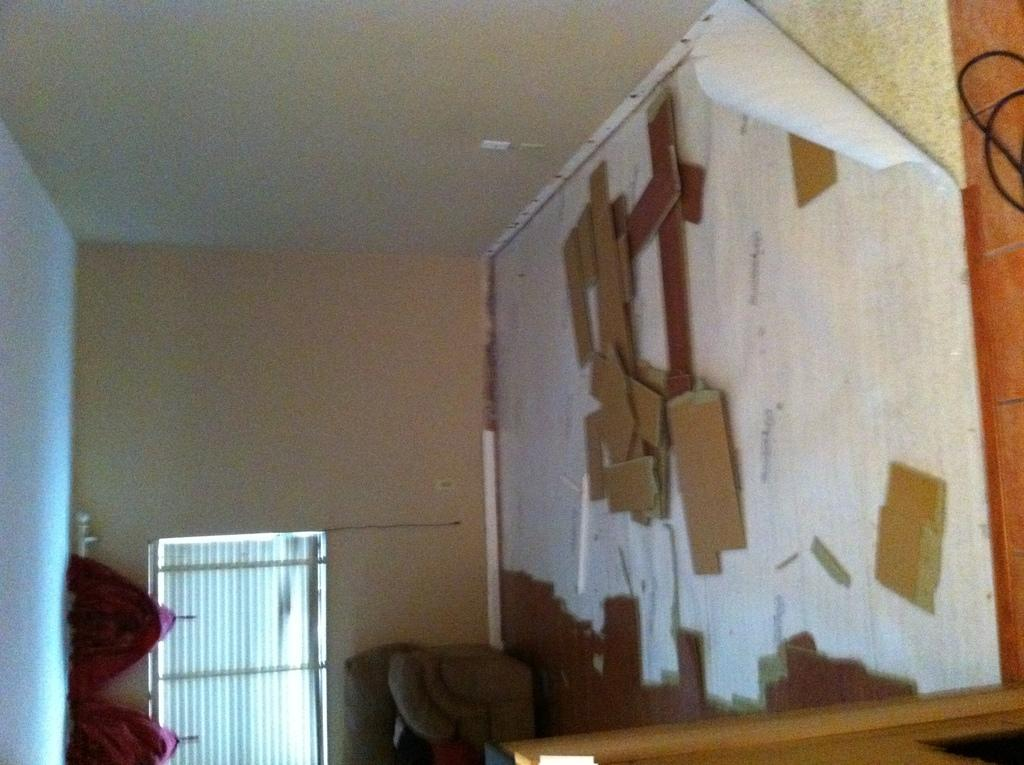What is the main object in the image? There is a door in the image. Are there any additional objects or features near the door? Yes, there are wooden sticks on the wall on the left side of the door. What color is the bubble that appears next to the door in the image? There is no bubble present in the image. 